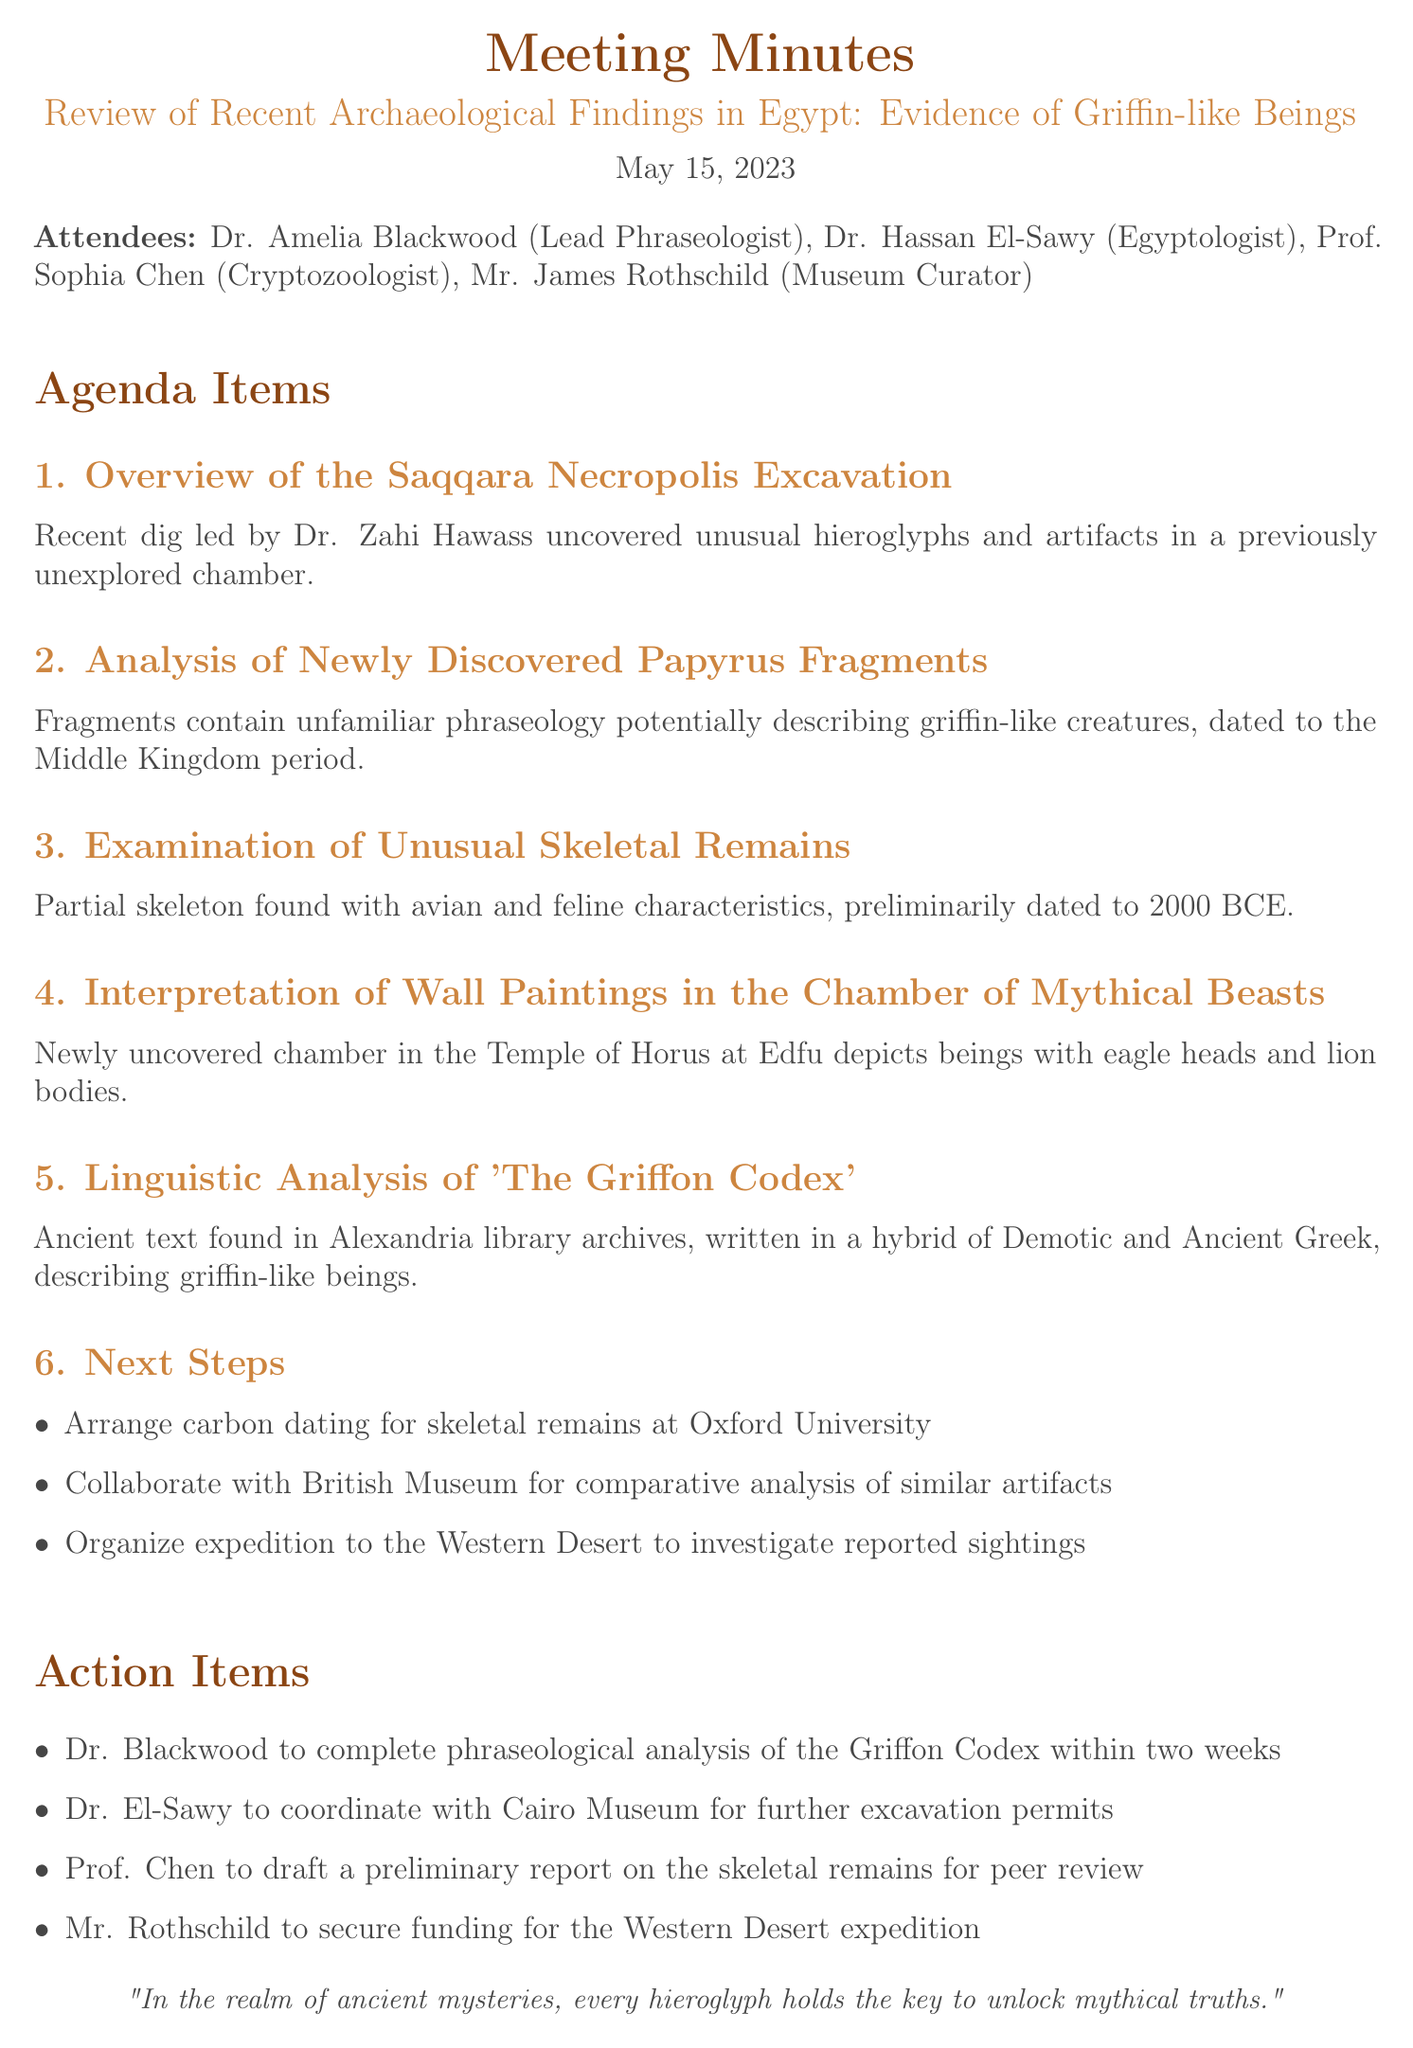What is the date of the meeting? The date of the meeting is explicitly mentioned at the beginning of the document.
Answer: May 15, 2023 Who conducted the excavation at Saqqara Necropolis? The excavation at Saqqara Necropolis was conducted by Dr. Zahi Hawass, as stated in the overview section.
Answer: Dr. Zahi Hawass What is the primary focus of the papyrus fragments analysis? The fragments reportedly contain unfamiliar phraseology, and the analysis suggests they describe griffin-like creatures.
Answer: Griffin-like creatures In which chamber were the wall paintings depicting mythical beings found? The wall paintings were discovered in the Temple of Horus at Edfu, according to the interpretation section.
Answer: Temple of Horus at Edfu What type of characteristics were found in the unusual skeletal remains? The skeletal remains were noted to have avian and feline characteristics, indicating a significant hybrid nature.
Answer: Avian and feline characteristics What is the main action item assigned to Dr. Blackwood? Dr. Blackwood's main action item is to complete the phraseological analysis of the Griffon Codex within a specified timeframe.
Answer: Phraseological analysis of the Griffon Codex How many attendees participated in the meeting? The number of attendees can be counted from the list provided at the beginning of the document.
Answer: Four What is one next step proposed after the findings? The document outlines several next steps; one is to arrange carbon dating for skeletal remains.
Answer: Arrange carbon dating for skeletal remains Which ancient text is mentioned in relation to griffin-like beings? The document specifically refers to 'The Griffon Codex' as the ancient text of interest in this context.
Answer: The Griffon Codex 